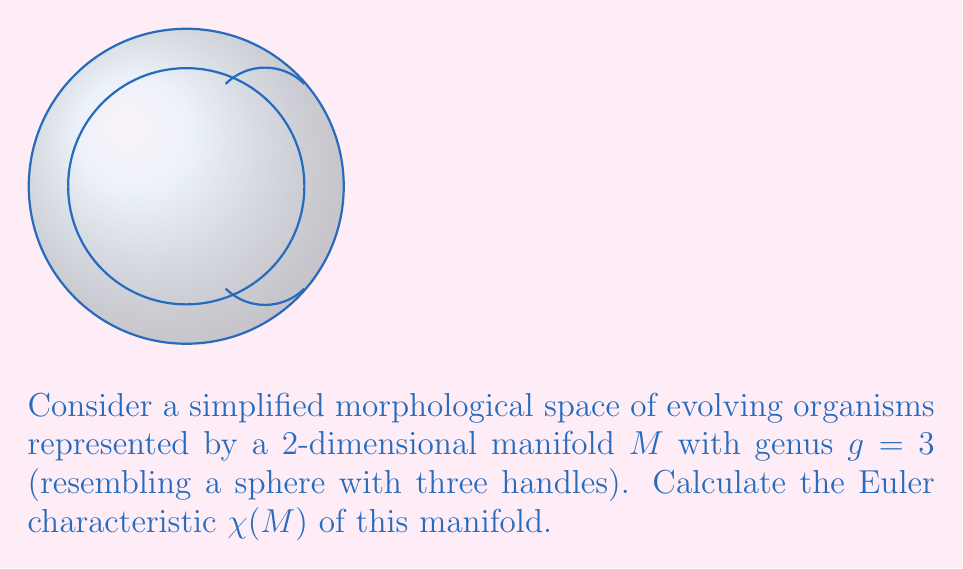Can you solve this math problem? To calculate the Euler characteristic of a manifold, we can use the following steps:

1. Recall the formula for the Euler characteristic of a closed, orientable surface:
   $$\chi(M) = 2 - 2g$$
   where $g$ is the genus of the surface.

2. In this case, we are given that the genus $g = 3$. This represents a sphere with three handles, which is topologically equivalent to a triple torus.

3. Substitute $g = 3$ into the formula:
   $$\chi(M) = 2 - 2(3)$$

4. Simplify:
   $$\chi(M) = 2 - 6 = -4$$

The negative Euler characteristic indicates that this surface has more holes than a sphere, which aligns with our understanding of a triple torus.

In the context of evolutionary biology, this simplified model could represent a morphological space where each handle corresponds to a distinct evolutionary pathway or phenotypic cluster. The Euler characteristic provides a topological invariant that captures some aspect of the complexity of this morphological space.
Answer: $\chi(M) = -4$ 